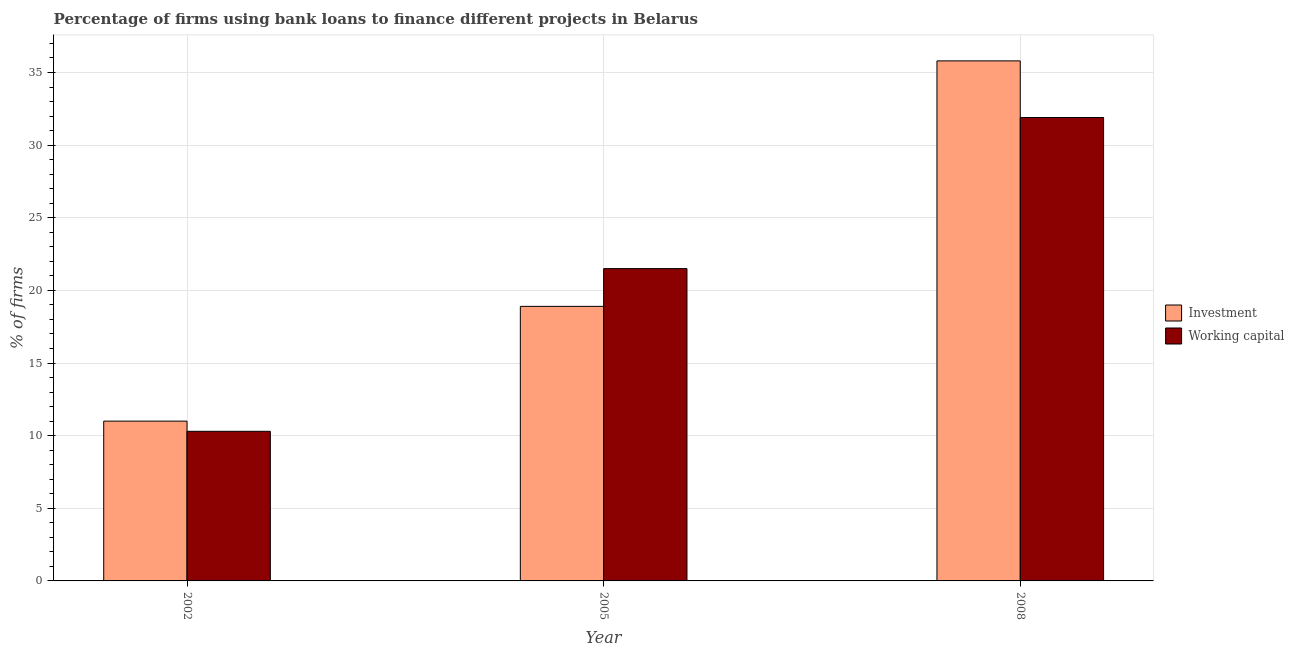How many different coloured bars are there?
Give a very brief answer. 2. Are the number of bars on each tick of the X-axis equal?
Offer a terse response. Yes. In how many cases, is the number of bars for a given year not equal to the number of legend labels?
Keep it short and to the point. 0. What is the percentage of firms using banks to finance investment in 2008?
Ensure brevity in your answer.  35.8. Across all years, what is the maximum percentage of firms using banks to finance working capital?
Offer a terse response. 31.9. Across all years, what is the minimum percentage of firms using banks to finance working capital?
Provide a succinct answer. 10.3. In which year was the percentage of firms using banks to finance working capital maximum?
Provide a succinct answer. 2008. What is the total percentage of firms using banks to finance investment in the graph?
Your answer should be very brief. 65.7. What is the difference between the percentage of firms using banks to finance investment in 2005 and that in 2008?
Keep it short and to the point. -16.9. What is the difference between the percentage of firms using banks to finance investment in 2008 and the percentage of firms using banks to finance working capital in 2002?
Offer a very short reply. 24.8. What is the average percentage of firms using banks to finance working capital per year?
Offer a very short reply. 21.23. What is the ratio of the percentage of firms using banks to finance working capital in 2005 to that in 2008?
Your answer should be very brief. 0.67. Is the difference between the percentage of firms using banks to finance working capital in 2005 and 2008 greater than the difference between the percentage of firms using banks to finance investment in 2005 and 2008?
Ensure brevity in your answer.  No. What is the difference between the highest and the lowest percentage of firms using banks to finance working capital?
Keep it short and to the point. 21.6. In how many years, is the percentage of firms using banks to finance investment greater than the average percentage of firms using banks to finance investment taken over all years?
Your answer should be very brief. 1. What does the 2nd bar from the left in 2002 represents?
Provide a short and direct response. Working capital. What does the 1st bar from the right in 2005 represents?
Provide a succinct answer. Working capital. How many bars are there?
Offer a terse response. 6. Does the graph contain any zero values?
Offer a very short reply. No. Does the graph contain grids?
Offer a terse response. Yes. Where does the legend appear in the graph?
Give a very brief answer. Center right. How are the legend labels stacked?
Offer a very short reply. Vertical. What is the title of the graph?
Make the answer very short. Percentage of firms using bank loans to finance different projects in Belarus. What is the label or title of the X-axis?
Your response must be concise. Year. What is the label or title of the Y-axis?
Your response must be concise. % of firms. What is the % of firms of Investment in 2002?
Give a very brief answer. 11. What is the % of firms in Investment in 2005?
Offer a very short reply. 18.9. What is the % of firms of Working capital in 2005?
Offer a very short reply. 21.5. What is the % of firms of Investment in 2008?
Provide a succinct answer. 35.8. What is the % of firms of Working capital in 2008?
Your response must be concise. 31.9. Across all years, what is the maximum % of firms in Investment?
Provide a short and direct response. 35.8. Across all years, what is the maximum % of firms of Working capital?
Provide a short and direct response. 31.9. What is the total % of firms of Investment in the graph?
Keep it short and to the point. 65.7. What is the total % of firms in Working capital in the graph?
Offer a terse response. 63.7. What is the difference between the % of firms in Investment in 2002 and that in 2008?
Provide a short and direct response. -24.8. What is the difference between the % of firms in Working capital in 2002 and that in 2008?
Your answer should be very brief. -21.6. What is the difference between the % of firms in Investment in 2005 and that in 2008?
Provide a succinct answer. -16.9. What is the difference between the % of firms in Investment in 2002 and the % of firms in Working capital in 2005?
Give a very brief answer. -10.5. What is the difference between the % of firms in Investment in 2002 and the % of firms in Working capital in 2008?
Your answer should be compact. -20.9. What is the average % of firms of Investment per year?
Provide a short and direct response. 21.9. What is the average % of firms of Working capital per year?
Make the answer very short. 21.23. In the year 2002, what is the difference between the % of firms of Investment and % of firms of Working capital?
Give a very brief answer. 0.7. In the year 2008, what is the difference between the % of firms in Investment and % of firms in Working capital?
Make the answer very short. 3.9. What is the ratio of the % of firms in Investment in 2002 to that in 2005?
Offer a terse response. 0.58. What is the ratio of the % of firms of Working capital in 2002 to that in 2005?
Keep it short and to the point. 0.48. What is the ratio of the % of firms of Investment in 2002 to that in 2008?
Your response must be concise. 0.31. What is the ratio of the % of firms in Working capital in 2002 to that in 2008?
Your response must be concise. 0.32. What is the ratio of the % of firms of Investment in 2005 to that in 2008?
Provide a short and direct response. 0.53. What is the ratio of the % of firms of Working capital in 2005 to that in 2008?
Provide a succinct answer. 0.67. What is the difference between the highest and the second highest % of firms in Investment?
Offer a very short reply. 16.9. What is the difference between the highest and the lowest % of firms in Investment?
Give a very brief answer. 24.8. What is the difference between the highest and the lowest % of firms in Working capital?
Ensure brevity in your answer.  21.6. 